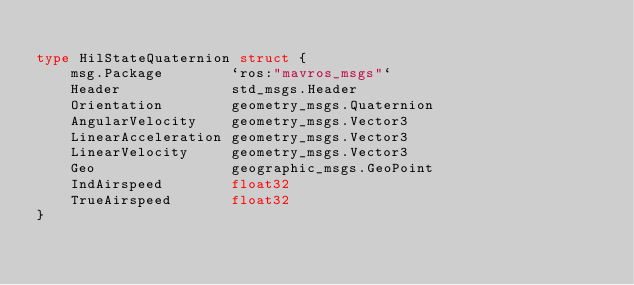<code> <loc_0><loc_0><loc_500><loc_500><_Go_>
type HilStateQuaternion struct {
	msg.Package        `ros:"mavros_msgs"`
	Header             std_msgs.Header
	Orientation        geometry_msgs.Quaternion
	AngularVelocity    geometry_msgs.Vector3
	LinearAcceleration geometry_msgs.Vector3
	LinearVelocity     geometry_msgs.Vector3
	Geo                geographic_msgs.GeoPoint
	IndAirspeed        float32
	TrueAirspeed       float32
}
</code> 